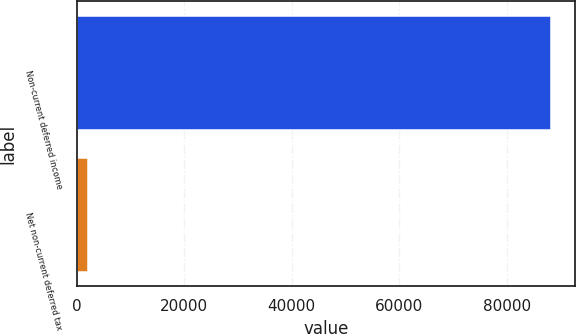<chart> <loc_0><loc_0><loc_500><loc_500><bar_chart><fcel>Non-current deferred income<fcel>Net non-current deferred tax<nl><fcel>88265<fcel>2205<nl></chart> 